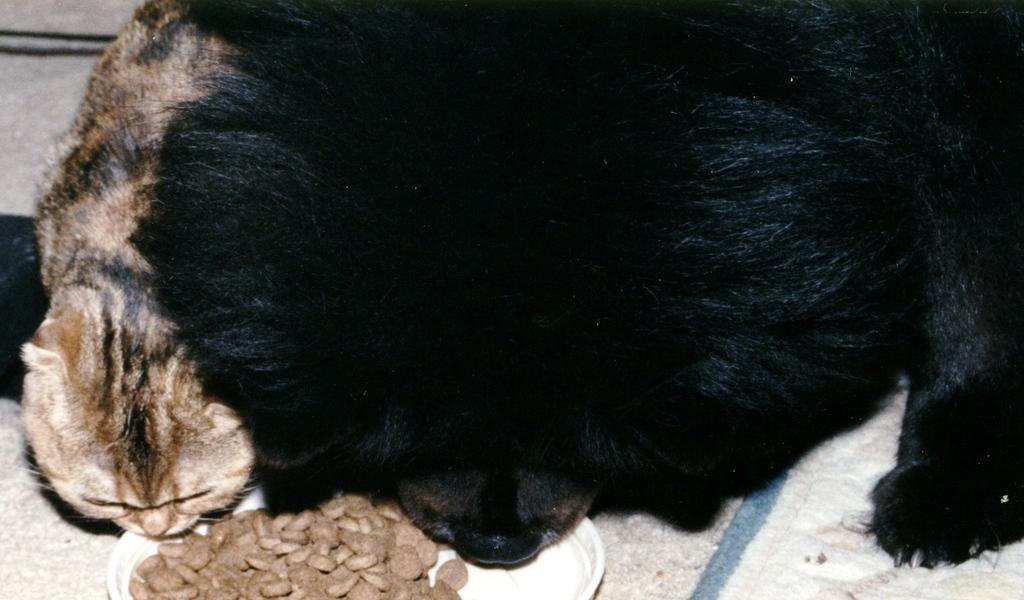Describe this image in one or two sentences. In this picture there is a dog and cat sitting on the floor. There is food on the plate. At the bottom it looks like a mat on the floor. 